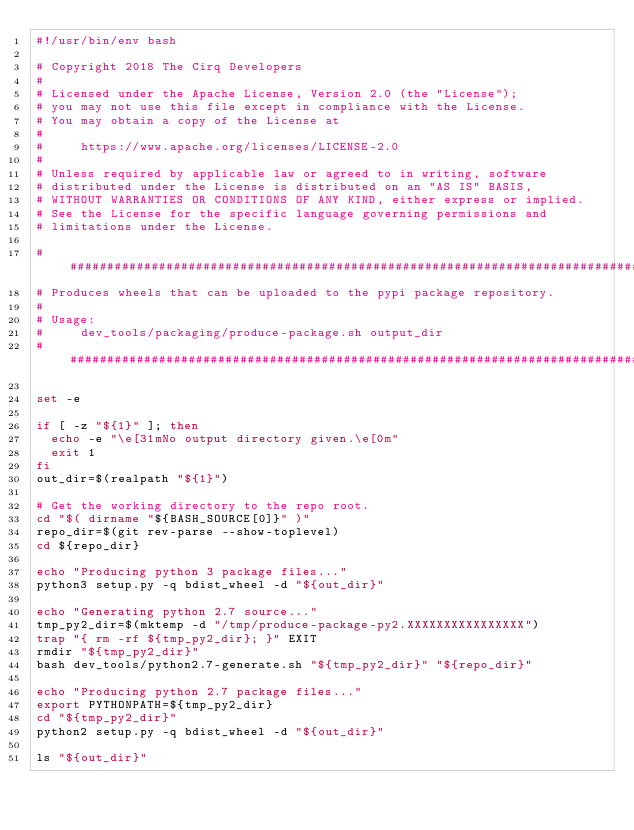<code> <loc_0><loc_0><loc_500><loc_500><_Bash_>#!/usr/bin/env bash

# Copyright 2018 The Cirq Developers
#
# Licensed under the Apache License, Version 2.0 (the "License");
# you may not use this file except in compliance with the License.
# You may obtain a copy of the License at
#
#     https://www.apache.org/licenses/LICENSE-2.0
#
# Unless required by applicable law or agreed to in writing, software
# distributed under the License is distributed on an "AS IS" BASIS,
# WITHOUT WARRANTIES OR CONDITIONS OF ANY KIND, either express or implied.
# See the License for the specific language governing permissions and
# limitations under the License.

################################################################################
# Produces wheels that can be uploaded to the pypi package repository.
#
# Usage:
#     dev_tools/packaging/produce-package.sh output_dir
################################################################################

set -e

if [ -z "${1}" ]; then
  echo -e "\e[31mNo output directory given.\e[0m"
  exit 1
fi
out_dir=$(realpath "${1}")

# Get the working directory to the repo root.
cd "$( dirname "${BASH_SOURCE[0]}" )"
repo_dir=$(git rev-parse --show-toplevel)
cd ${repo_dir}

echo "Producing python 3 package files..."
python3 setup.py -q bdist_wheel -d "${out_dir}"

echo "Generating python 2.7 source..."
tmp_py2_dir=$(mktemp -d "/tmp/produce-package-py2.XXXXXXXXXXXXXXXX")
trap "{ rm -rf ${tmp_py2_dir}; }" EXIT
rmdir "${tmp_py2_dir}"
bash dev_tools/python2.7-generate.sh "${tmp_py2_dir}" "${repo_dir}"

echo "Producing python 2.7 package files..."
export PYTHONPATH=${tmp_py2_dir}
cd "${tmp_py2_dir}"
python2 setup.py -q bdist_wheel -d "${out_dir}"

ls "${out_dir}"
</code> 